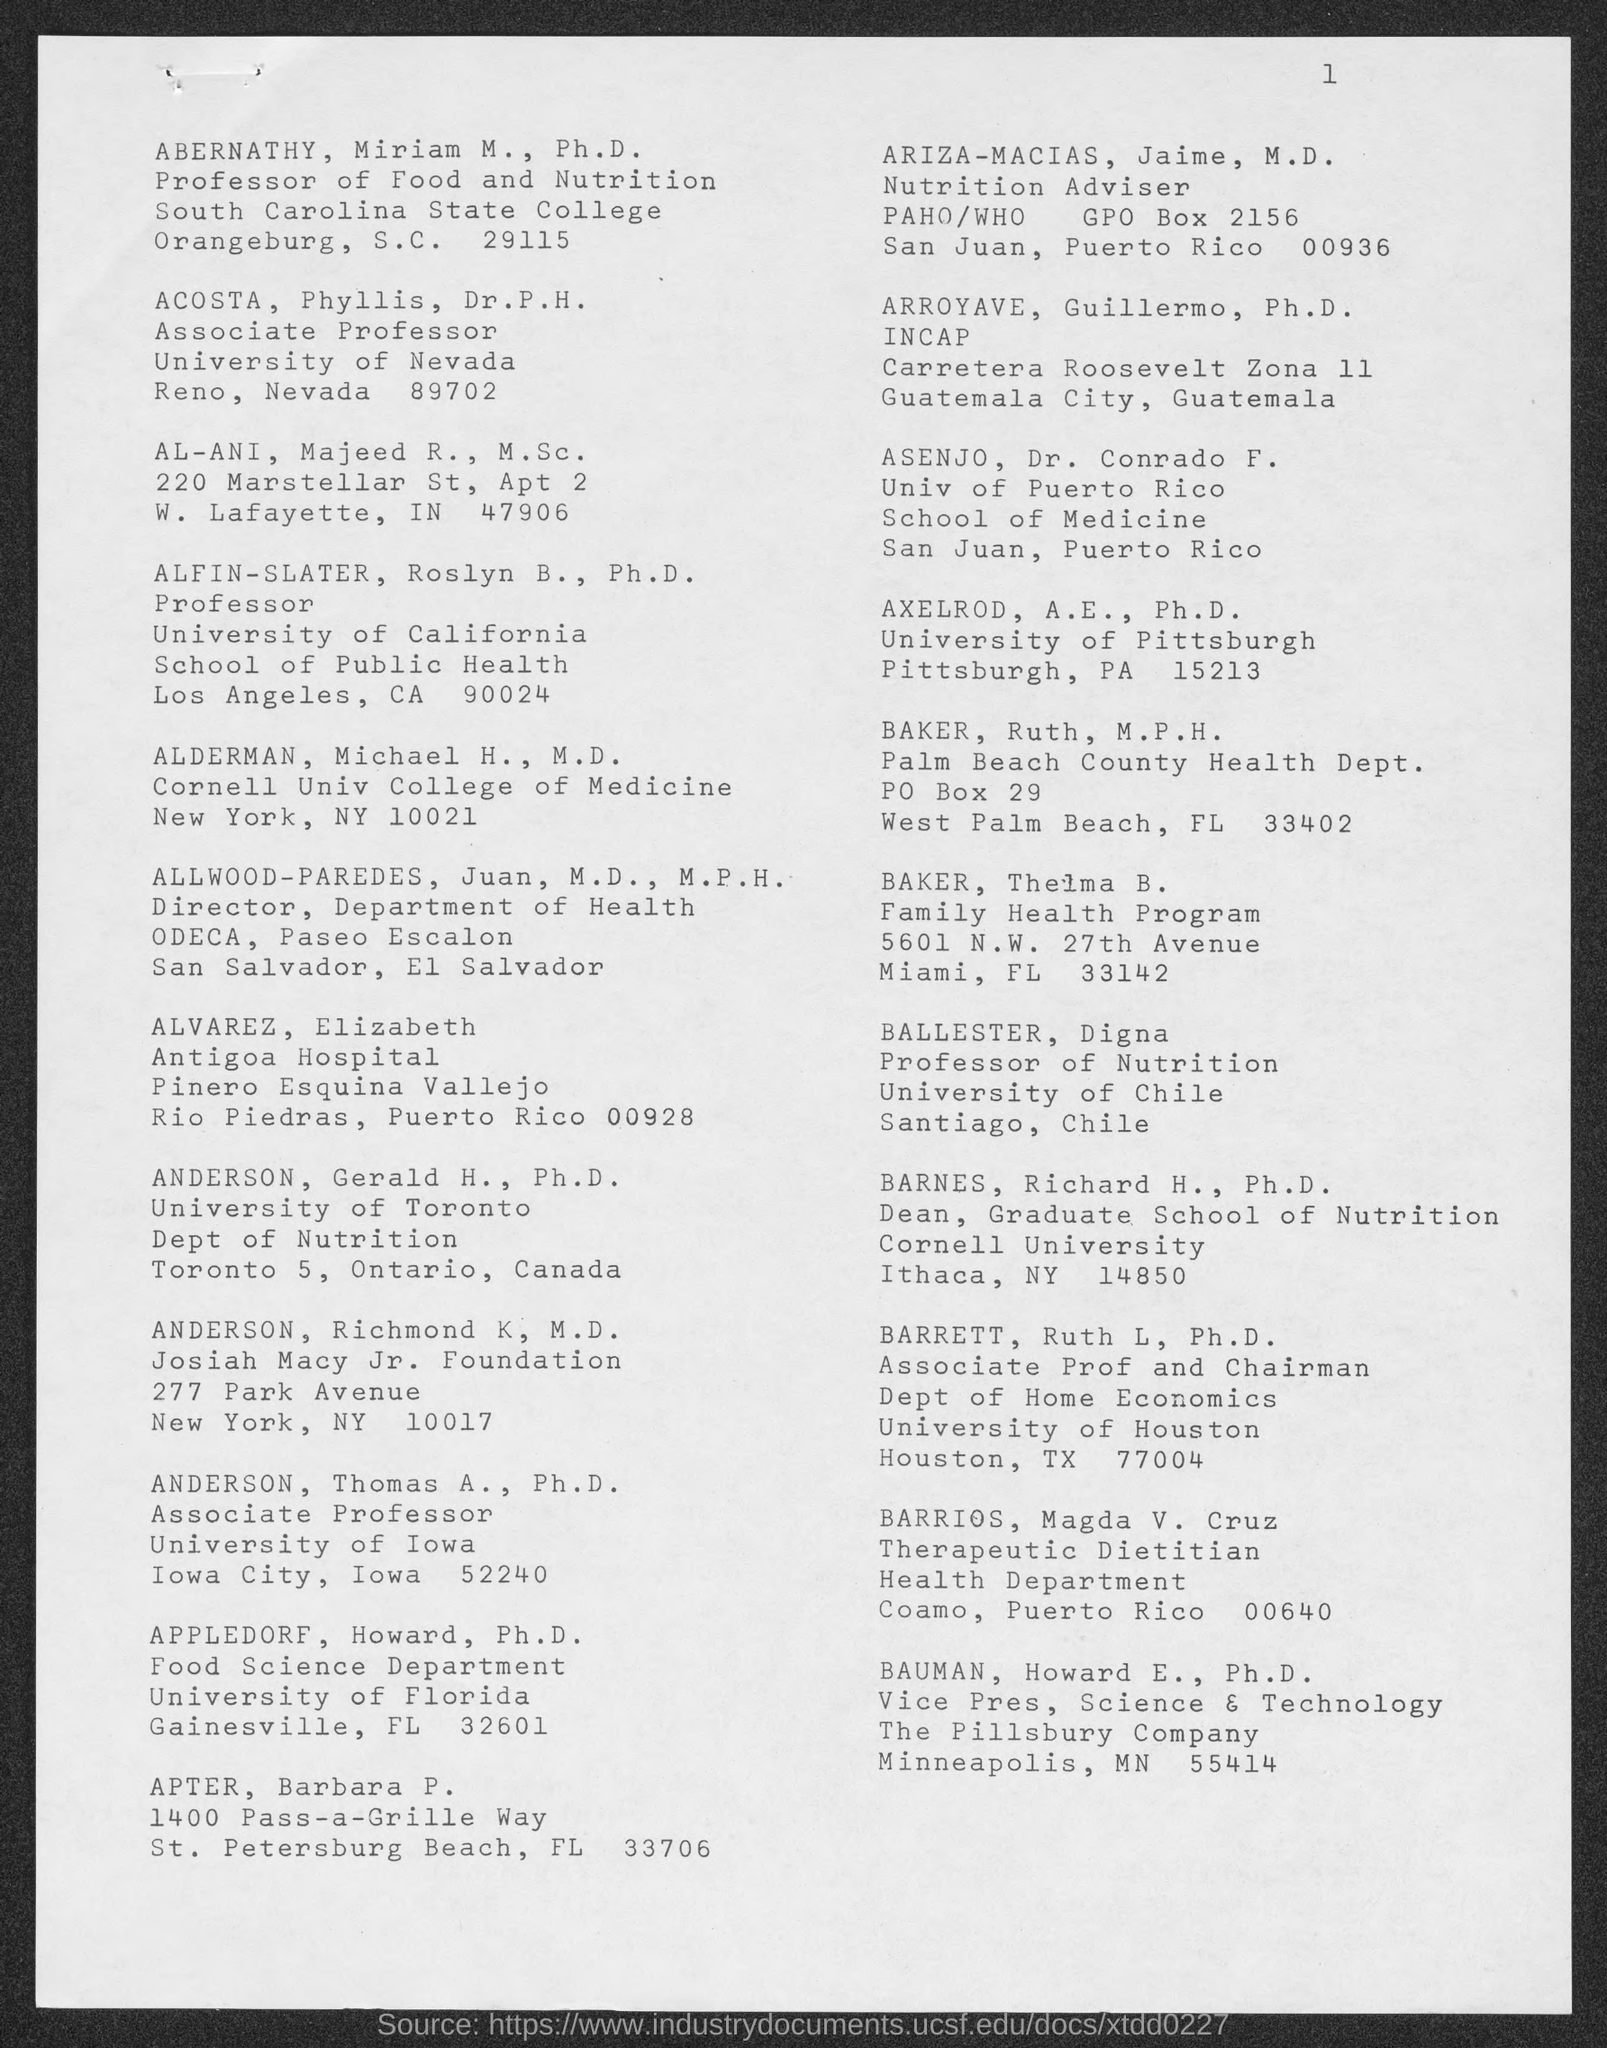What is the page number on this document?
Your response must be concise. 1. Who is the Professor of Food and Nutrition in South Carolina State College?
Ensure brevity in your answer.  ABERNATHY, Miriam M., Ph.D. What is ACOSTA, Phyllis, Dr. P. H.'s designation?
Ensure brevity in your answer.  Associate Professor. Which university is ALFIN-SLATER, Roslyn B., Ph.D. part of?
Offer a terse response. University of California. Which Dept. is BAKER, Ruth, M.P.H. part of?
Provide a succinct answer. Palm Beach County Health Dept. Who is the vice president, Science and Technology of The Pillsbury Company?
Give a very brief answer. BAUMAN, Howard E., Ph.D. 